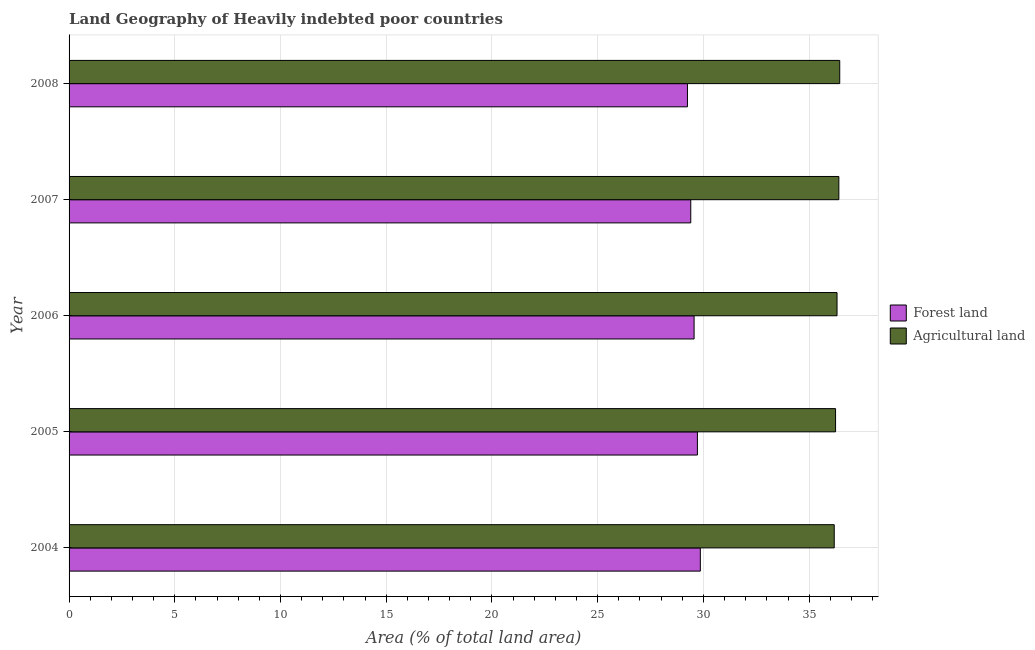How many different coloured bars are there?
Provide a succinct answer. 2. How many bars are there on the 5th tick from the top?
Your answer should be very brief. 2. How many bars are there on the 3rd tick from the bottom?
Keep it short and to the point. 2. In how many cases, is the number of bars for a given year not equal to the number of legend labels?
Keep it short and to the point. 0. What is the percentage of land area under agriculture in 2007?
Your response must be concise. 36.4. Across all years, what is the maximum percentage of land area under agriculture?
Provide a succinct answer. 36.45. Across all years, what is the minimum percentage of land area under forests?
Your response must be concise. 29.24. In which year was the percentage of land area under agriculture maximum?
Make the answer very short. 2008. In which year was the percentage of land area under forests minimum?
Offer a very short reply. 2008. What is the total percentage of land area under agriculture in the graph?
Ensure brevity in your answer.  181.61. What is the difference between the percentage of land area under agriculture in 2005 and that in 2008?
Your answer should be very brief. -0.2. What is the difference between the percentage of land area under forests in 2008 and the percentage of land area under agriculture in 2007?
Provide a short and direct response. -7.16. What is the average percentage of land area under agriculture per year?
Your answer should be compact. 36.32. In the year 2005, what is the difference between the percentage of land area under forests and percentage of land area under agriculture?
Offer a very short reply. -6.53. Is the percentage of land area under agriculture in 2005 less than that in 2006?
Offer a terse response. Yes. What is the difference between the highest and the second highest percentage of land area under agriculture?
Offer a terse response. 0.04. What is the difference between the highest and the lowest percentage of land area under forests?
Your answer should be very brief. 0.61. What does the 1st bar from the top in 2007 represents?
Your response must be concise. Agricultural land. What does the 2nd bar from the bottom in 2008 represents?
Offer a terse response. Agricultural land. Are all the bars in the graph horizontal?
Make the answer very short. Yes. What is the difference between two consecutive major ticks on the X-axis?
Offer a very short reply. 5. Are the values on the major ticks of X-axis written in scientific E-notation?
Give a very brief answer. No. Does the graph contain grids?
Ensure brevity in your answer.  Yes. What is the title of the graph?
Offer a terse response. Land Geography of Heavily indebted poor countries. Does "IMF concessional" appear as one of the legend labels in the graph?
Your answer should be very brief. No. What is the label or title of the X-axis?
Make the answer very short. Area (% of total land area). What is the Area (% of total land area) in Forest land in 2004?
Offer a terse response. 29.85. What is the Area (% of total land area) of Agricultural land in 2004?
Make the answer very short. 36.19. What is the Area (% of total land area) of Forest land in 2005?
Your answer should be very brief. 29.72. What is the Area (% of total land area) of Agricultural land in 2005?
Your response must be concise. 36.25. What is the Area (% of total land area) of Forest land in 2006?
Give a very brief answer. 29.56. What is the Area (% of total land area) of Agricultural land in 2006?
Offer a terse response. 36.32. What is the Area (% of total land area) in Forest land in 2007?
Provide a short and direct response. 29.4. What is the Area (% of total land area) of Agricultural land in 2007?
Give a very brief answer. 36.4. What is the Area (% of total land area) of Forest land in 2008?
Your response must be concise. 29.24. What is the Area (% of total land area) of Agricultural land in 2008?
Ensure brevity in your answer.  36.45. Across all years, what is the maximum Area (% of total land area) of Forest land?
Offer a terse response. 29.85. Across all years, what is the maximum Area (% of total land area) in Agricultural land?
Keep it short and to the point. 36.45. Across all years, what is the minimum Area (% of total land area) in Forest land?
Give a very brief answer. 29.24. Across all years, what is the minimum Area (% of total land area) of Agricultural land?
Ensure brevity in your answer.  36.19. What is the total Area (% of total land area) in Forest land in the graph?
Offer a terse response. 147.78. What is the total Area (% of total land area) in Agricultural land in the graph?
Your answer should be compact. 181.61. What is the difference between the Area (% of total land area) of Forest land in 2004 and that in 2005?
Ensure brevity in your answer.  0.14. What is the difference between the Area (% of total land area) of Agricultural land in 2004 and that in 2005?
Provide a succinct answer. -0.06. What is the difference between the Area (% of total land area) of Forest land in 2004 and that in 2006?
Your response must be concise. 0.3. What is the difference between the Area (% of total land area) of Agricultural land in 2004 and that in 2006?
Your answer should be compact. -0.13. What is the difference between the Area (% of total land area) in Forest land in 2004 and that in 2007?
Ensure brevity in your answer.  0.45. What is the difference between the Area (% of total land area) in Agricultural land in 2004 and that in 2007?
Give a very brief answer. -0.22. What is the difference between the Area (% of total land area) of Forest land in 2004 and that in 2008?
Provide a short and direct response. 0.61. What is the difference between the Area (% of total land area) in Agricultural land in 2004 and that in 2008?
Offer a terse response. -0.26. What is the difference between the Area (% of total land area) of Forest land in 2005 and that in 2006?
Provide a succinct answer. 0.16. What is the difference between the Area (% of total land area) in Agricultural land in 2005 and that in 2006?
Your answer should be very brief. -0.07. What is the difference between the Area (% of total land area) of Forest land in 2005 and that in 2007?
Give a very brief answer. 0.31. What is the difference between the Area (% of total land area) of Agricultural land in 2005 and that in 2007?
Provide a succinct answer. -0.16. What is the difference between the Area (% of total land area) in Forest land in 2005 and that in 2008?
Make the answer very short. 0.47. What is the difference between the Area (% of total land area) in Agricultural land in 2005 and that in 2008?
Offer a terse response. -0.2. What is the difference between the Area (% of total land area) in Forest land in 2006 and that in 2007?
Your response must be concise. 0.16. What is the difference between the Area (% of total land area) in Agricultural land in 2006 and that in 2007?
Offer a terse response. -0.09. What is the difference between the Area (% of total land area) in Forest land in 2006 and that in 2008?
Offer a very short reply. 0.31. What is the difference between the Area (% of total land area) in Agricultural land in 2006 and that in 2008?
Provide a short and direct response. -0.13. What is the difference between the Area (% of total land area) in Forest land in 2007 and that in 2008?
Keep it short and to the point. 0.16. What is the difference between the Area (% of total land area) in Agricultural land in 2007 and that in 2008?
Provide a short and direct response. -0.04. What is the difference between the Area (% of total land area) in Forest land in 2004 and the Area (% of total land area) in Agricultural land in 2005?
Your answer should be very brief. -6.4. What is the difference between the Area (% of total land area) in Forest land in 2004 and the Area (% of total land area) in Agricultural land in 2006?
Ensure brevity in your answer.  -6.46. What is the difference between the Area (% of total land area) of Forest land in 2004 and the Area (% of total land area) of Agricultural land in 2007?
Offer a terse response. -6.55. What is the difference between the Area (% of total land area) in Forest land in 2004 and the Area (% of total land area) in Agricultural land in 2008?
Offer a terse response. -6.59. What is the difference between the Area (% of total land area) in Forest land in 2005 and the Area (% of total land area) in Agricultural land in 2006?
Your answer should be very brief. -6.6. What is the difference between the Area (% of total land area) of Forest land in 2005 and the Area (% of total land area) of Agricultural land in 2007?
Your answer should be very brief. -6.69. What is the difference between the Area (% of total land area) of Forest land in 2005 and the Area (% of total land area) of Agricultural land in 2008?
Your answer should be compact. -6.73. What is the difference between the Area (% of total land area) in Forest land in 2006 and the Area (% of total land area) in Agricultural land in 2007?
Offer a terse response. -6.85. What is the difference between the Area (% of total land area) in Forest land in 2006 and the Area (% of total land area) in Agricultural land in 2008?
Offer a very short reply. -6.89. What is the difference between the Area (% of total land area) of Forest land in 2007 and the Area (% of total land area) of Agricultural land in 2008?
Offer a terse response. -7.05. What is the average Area (% of total land area) in Forest land per year?
Keep it short and to the point. 29.56. What is the average Area (% of total land area) in Agricultural land per year?
Ensure brevity in your answer.  36.32. In the year 2004, what is the difference between the Area (% of total land area) of Forest land and Area (% of total land area) of Agricultural land?
Provide a short and direct response. -6.33. In the year 2005, what is the difference between the Area (% of total land area) of Forest land and Area (% of total land area) of Agricultural land?
Your answer should be very brief. -6.53. In the year 2006, what is the difference between the Area (% of total land area) in Forest land and Area (% of total land area) in Agricultural land?
Your answer should be very brief. -6.76. In the year 2007, what is the difference between the Area (% of total land area) of Forest land and Area (% of total land area) of Agricultural land?
Offer a terse response. -7. In the year 2008, what is the difference between the Area (% of total land area) in Forest land and Area (% of total land area) in Agricultural land?
Provide a short and direct response. -7.2. What is the ratio of the Area (% of total land area) in Agricultural land in 2004 to that in 2005?
Your answer should be very brief. 1. What is the ratio of the Area (% of total land area) in Agricultural land in 2004 to that in 2006?
Offer a terse response. 1. What is the ratio of the Area (% of total land area) of Forest land in 2004 to that in 2007?
Offer a terse response. 1.02. What is the ratio of the Area (% of total land area) in Forest land in 2004 to that in 2008?
Give a very brief answer. 1.02. What is the ratio of the Area (% of total land area) in Agricultural land in 2004 to that in 2008?
Keep it short and to the point. 0.99. What is the ratio of the Area (% of total land area) in Forest land in 2005 to that in 2006?
Make the answer very short. 1.01. What is the ratio of the Area (% of total land area) in Forest land in 2005 to that in 2007?
Provide a short and direct response. 1.01. What is the ratio of the Area (% of total land area) of Forest land in 2005 to that in 2008?
Offer a very short reply. 1.02. What is the ratio of the Area (% of total land area) in Forest land in 2006 to that in 2008?
Keep it short and to the point. 1.01. What is the ratio of the Area (% of total land area) in Forest land in 2007 to that in 2008?
Make the answer very short. 1.01. What is the difference between the highest and the second highest Area (% of total land area) of Forest land?
Ensure brevity in your answer.  0.14. What is the difference between the highest and the second highest Area (% of total land area) in Agricultural land?
Offer a very short reply. 0.04. What is the difference between the highest and the lowest Area (% of total land area) of Forest land?
Keep it short and to the point. 0.61. What is the difference between the highest and the lowest Area (% of total land area) in Agricultural land?
Provide a short and direct response. 0.26. 